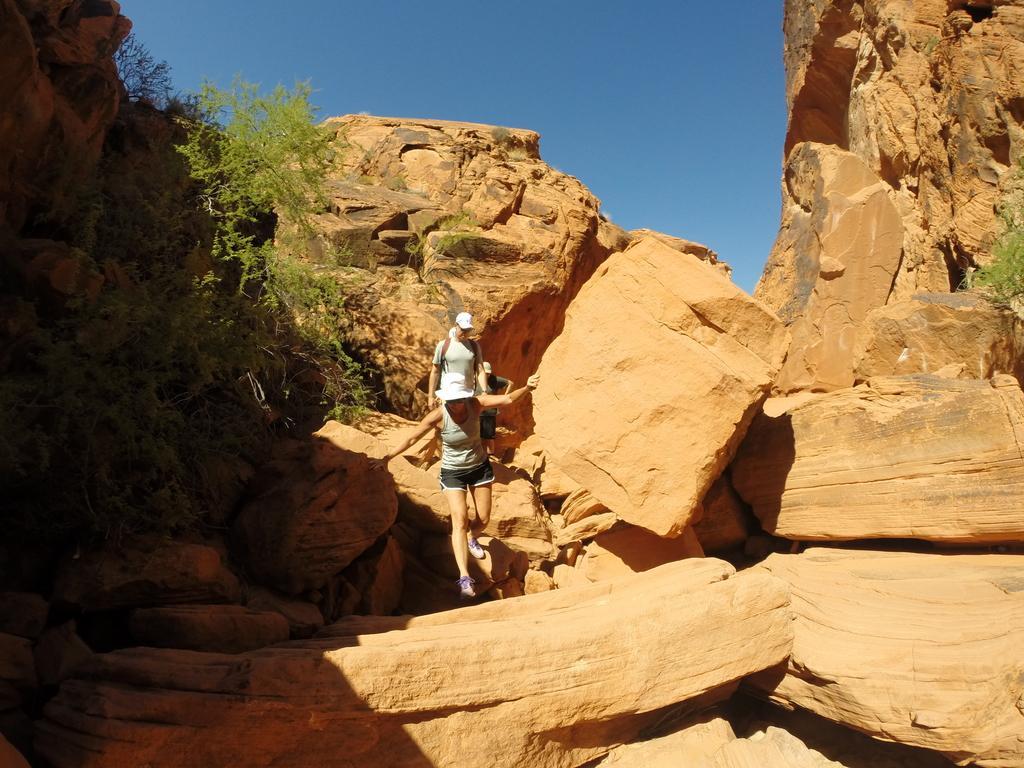In one or two sentences, can you explain what this image depicts? In this picture I can see few persons. There are rocks, trees, and in the background there is the sky. 